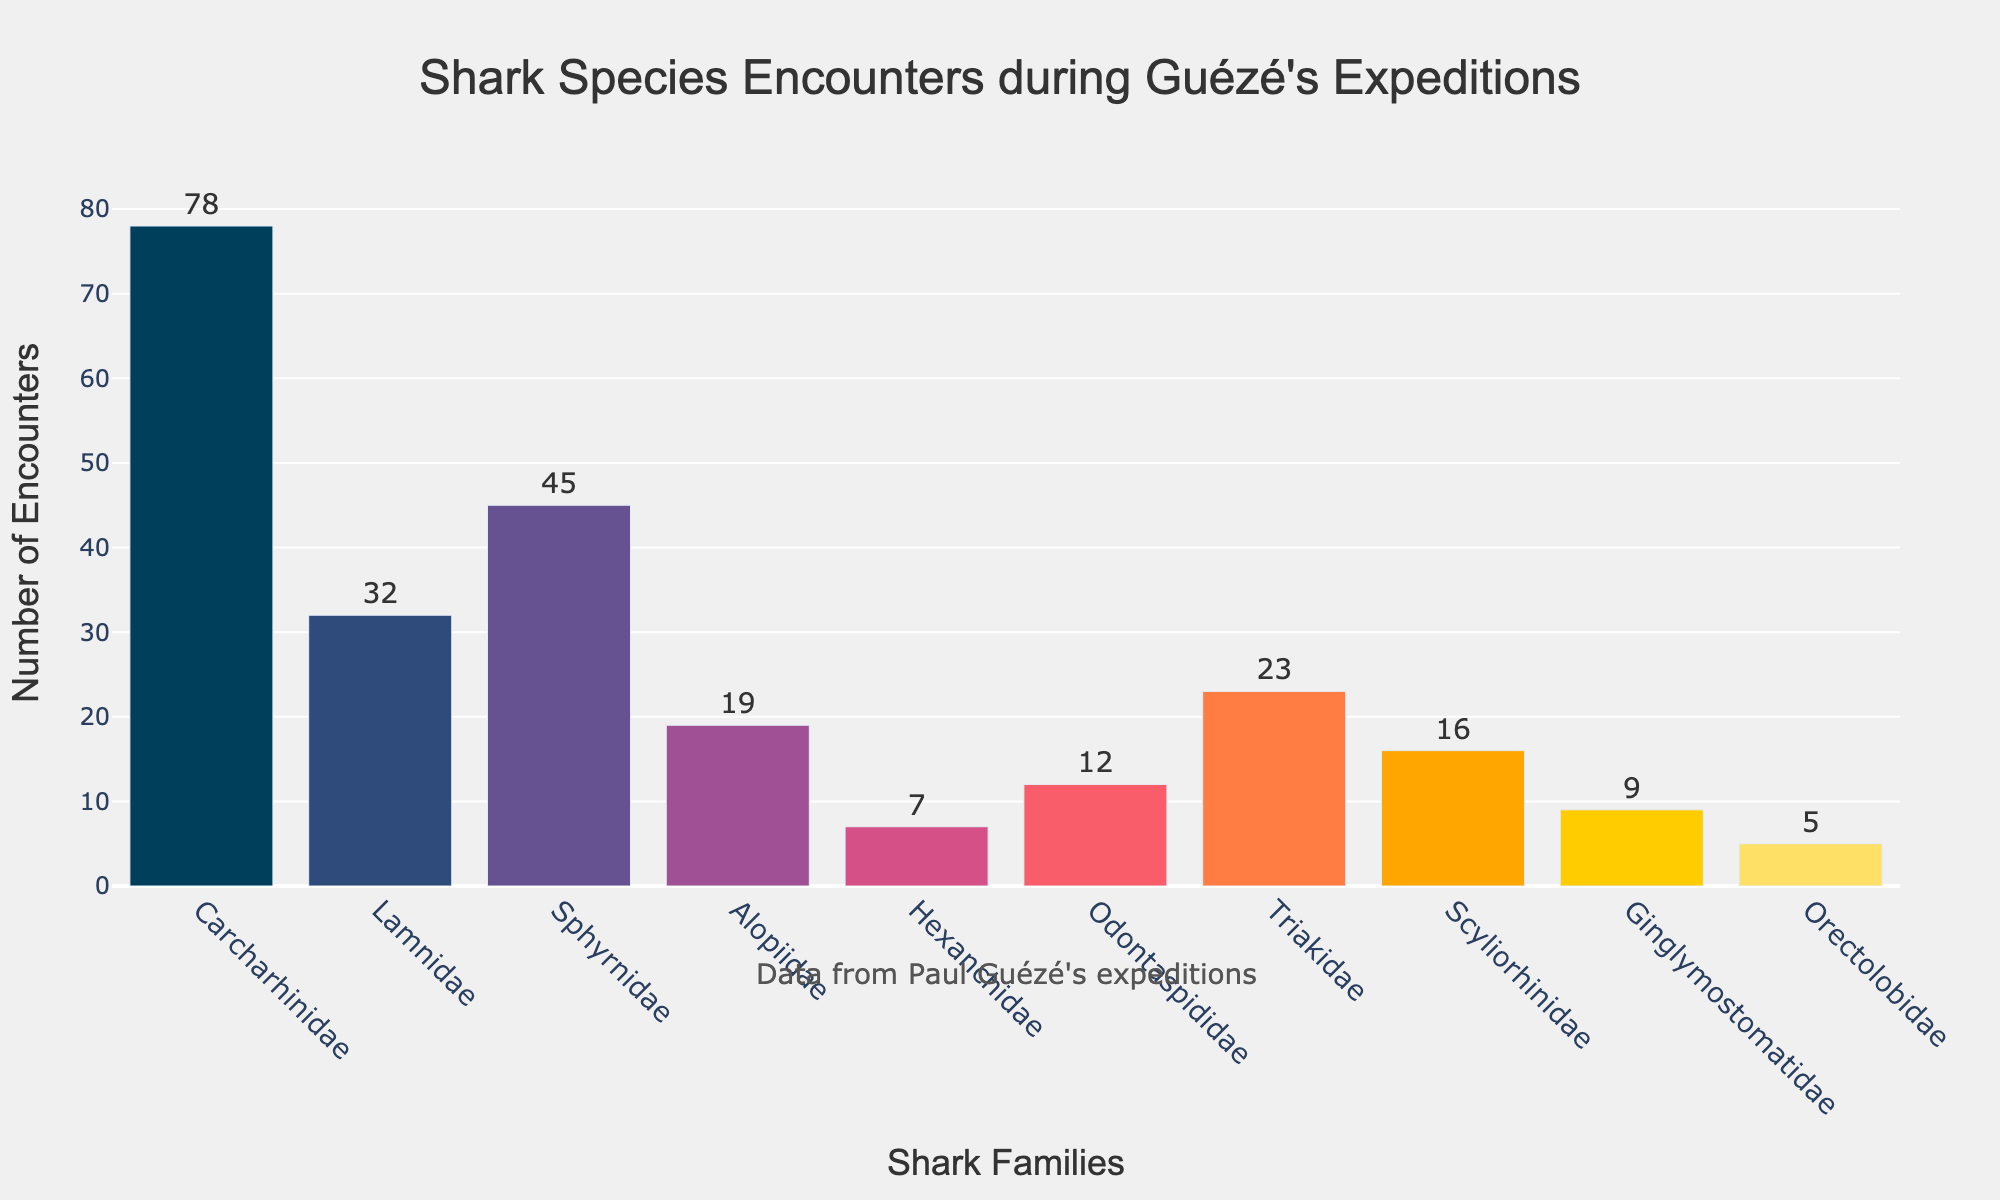What is the number of encounters for the Carcharhinidae family? Look at the bar representing the Carcharhinidae family and read the number associated with it.
Answer: 78 Which shark family had the fewest encounters, and what is that number? Identify the shortest bar in the figure, which corresponds to the fewest encounters, and read its label and the associated number of encounters.
Answer: Orectolobidae, 5 How many more encounters did the Carcharhinidae family have compared to the Lamnidae family? Subtract the number of encounters for the Lamnidae family from the number of encounters for the Carcharhinidae family (78 - 32).
Answer: 46 What is the total number of encounters for the Triakidae and Hexanchidae families combined? Add the number of encounters for the Triakidae family (23) to the number of encounters for the Hexanchidae family (7).
Answer: 30 Which shark family had more encounters, Sphyrnidae or Alopiidae, and by how much? Compare the bars for the Sphyrnidae and the Alopiidae families. Subtract the number of encounters for Alopiidae from the number of encounters for Sphyrnidae (45 - 19).
Answer: Sphyrnidae, 26 What is the average number of encounters across all shark families? Sum the number of encounters for all families (78 + 32 + 45 + 19 + 7 + 12 + 23 + 16 + 9 + 5 = 246) and divide by the number of families (10).
Answer: 24.6 Is the number of encounters for the Scyliorhinidae family greater than the average number of encounters across all shark families? First, determine the average number of encounters (24.6 from the previous question), then compare it with the number of encounters for the Scyliorhinidae family (16).
Answer: No Which shark family is represented by the blue-colored bar and what is the number of encounters for this family? Identify the blue-colored bar and read its label and the associated number of encounters. (The question assumes knowledge about color coding from provided information, the bar matches '#003f5c'.)
Answer: Carcharhinidae, 78 How many encounters did Odontaspididae and Ginglymostomatidae families have together? Add the number of encounters for the Odontaspididae family (12) to the number of encounters for the Ginglymostomatidae family (9).
Answer: 21 What is the difference in the number of encounters between the Triakidae and Orectolobidae families? Subtract the number of encounters for the Orectolobidae family from the number of encounters for the Triakidae family (23 - 5).
Answer: 18 